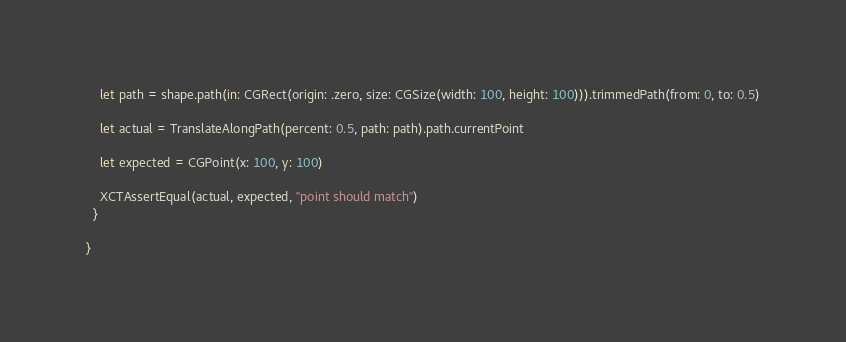<code> <loc_0><loc_0><loc_500><loc_500><_Swift_>    let path = shape.path(in: CGRect(origin: .zero, size: CGSize(width: 100, height: 100))).trimmedPath(from: 0, to: 0.5)
    
    let actual = TranslateAlongPath(percent: 0.5, path: path).path.currentPoint
    
    let expected = CGPoint(x: 100, y: 100)
    
    XCTAssertEqual(actual, expected, "point should match")
  }
  
}
</code> 